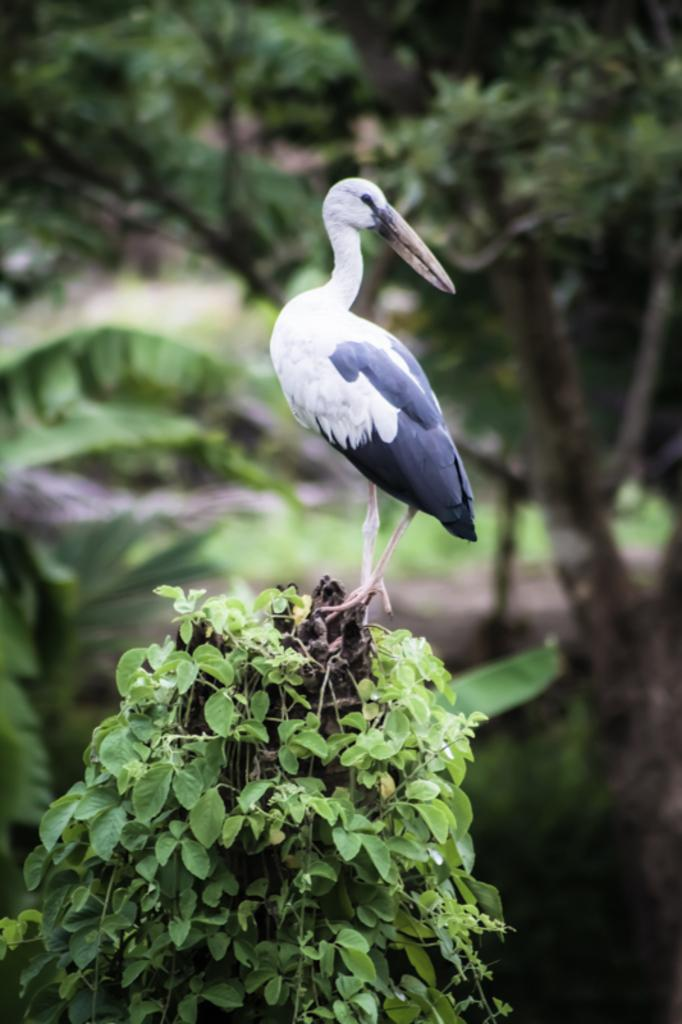What type of animal is present in the image? There is a bird in the image. Where is the bird located? The bird is standing in a bush with leaves. What can be seen in the background of the image? There are trees visible behind the bird. What type of lock can be seen securing the bird's perch in the image? There is no lock present in the image; the bird is standing in a bush with leaves. 